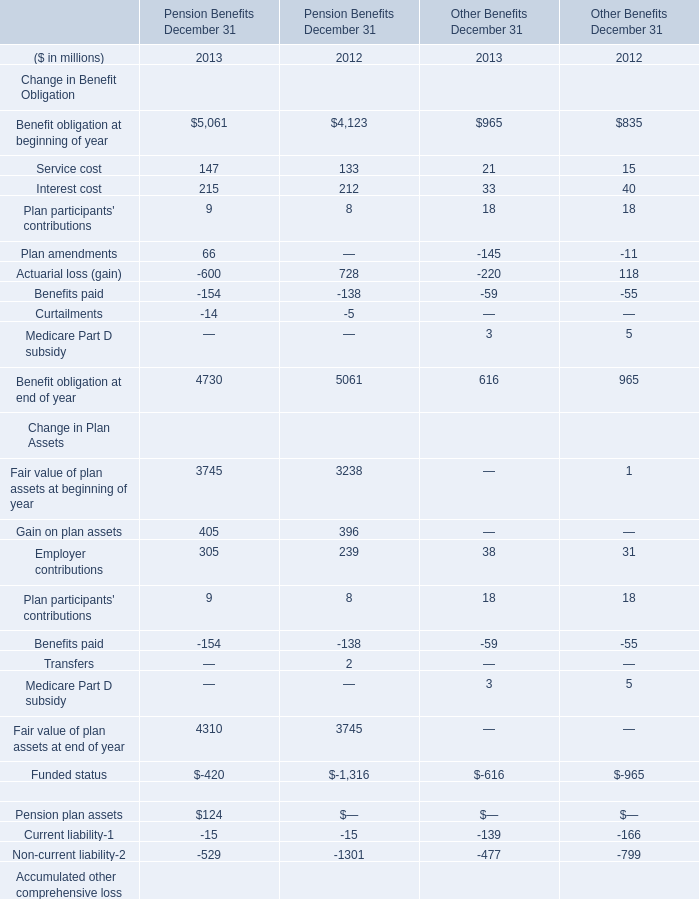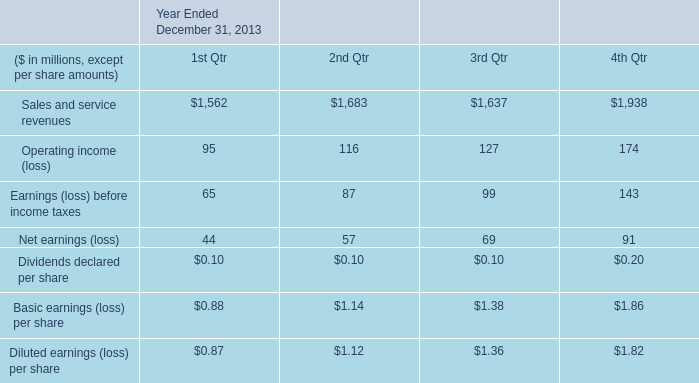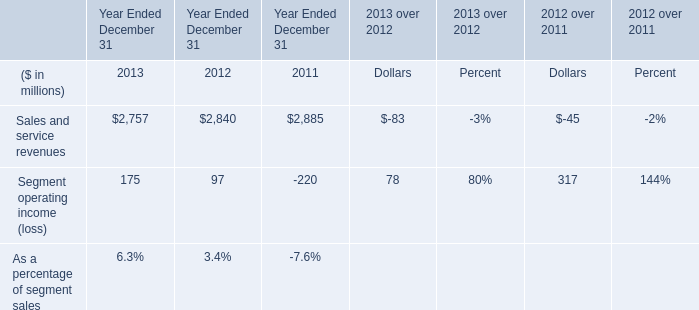What was the total amount of the Gain on plan assets in the years where Employer contributions greater than 0?? (in million) 
Computations: (405 + 396)
Answer: 801.0. 